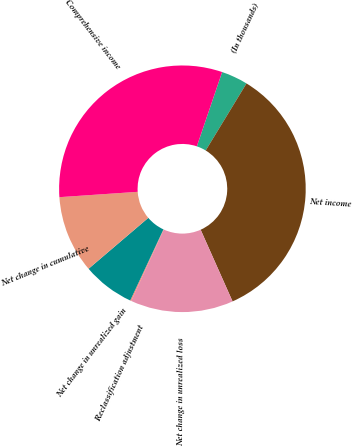Convert chart to OTSL. <chart><loc_0><loc_0><loc_500><loc_500><pie_chart><fcel>(In thousands)<fcel>Net income<fcel>Net change in unrealized loss<fcel>Reclassification adjustment<fcel>Net change in unrealized gain<fcel>Net change in cumulative<fcel>Comprehensive income<nl><fcel>3.48%<fcel>34.63%<fcel>13.48%<fcel>0.14%<fcel>6.81%<fcel>10.15%<fcel>31.3%<nl></chart> 